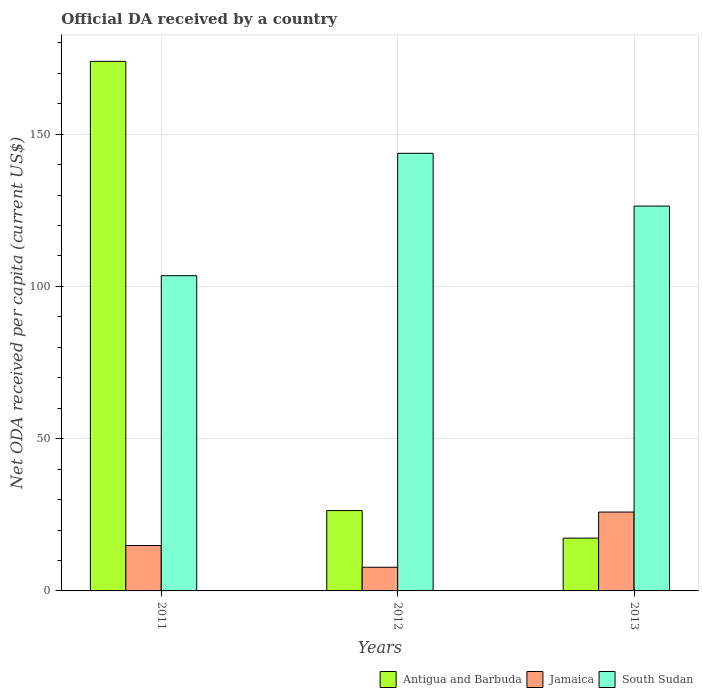How many groups of bars are there?
Make the answer very short. 3. Are the number of bars on each tick of the X-axis equal?
Your answer should be very brief. Yes. In how many cases, is the number of bars for a given year not equal to the number of legend labels?
Your answer should be compact. 0. What is the ODA received in in Jamaica in 2013?
Keep it short and to the point. 25.9. Across all years, what is the maximum ODA received in in Jamaica?
Your answer should be very brief. 25.9. Across all years, what is the minimum ODA received in in South Sudan?
Your answer should be very brief. 103.52. In which year was the ODA received in in Antigua and Barbuda maximum?
Offer a terse response. 2011. In which year was the ODA received in in Jamaica minimum?
Offer a very short reply. 2012. What is the total ODA received in in Antigua and Barbuda in the graph?
Provide a succinct answer. 217.62. What is the difference between the ODA received in in South Sudan in 2012 and that in 2013?
Offer a very short reply. 17.33. What is the difference between the ODA received in in Antigua and Barbuda in 2011 and the ODA received in in Jamaica in 2013?
Provide a succinct answer. 148. What is the average ODA received in in Antigua and Barbuda per year?
Ensure brevity in your answer.  72.54. In the year 2011, what is the difference between the ODA received in in Antigua and Barbuda and ODA received in in Jamaica?
Keep it short and to the point. 159. What is the ratio of the ODA received in in Antigua and Barbuda in 2011 to that in 2013?
Ensure brevity in your answer.  10.03. What is the difference between the highest and the second highest ODA received in in Antigua and Barbuda?
Provide a short and direct response. 147.52. What is the difference between the highest and the lowest ODA received in in Antigua and Barbuda?
Your answer should be compact. 156.57. Is the sum of the ODA received in in Jamaica in 2012 and 2013 greater than the maximum ODA received in in Antigua and Barbuda across all years?
Keep it short and to the point. No. What does the 1st bar from the left in 2012 represents?
Give a very brief answer. Antigua and Barbuda. What does the 2nd bar from the right in 2012 represents?
Your response must be concise. Jamaica. How many bars are there?
Offer a very short reply. 9. Are all the bars in the graph horizontal?
Give a very brief answer. No. Are the values on the major ticks of Y-axis written in scientific E-notation?
Give a very brief answer. No. Where does the legend appear in the graph?
Offer a very short reply. Bottom right. How are the legend labels stacked?
Ensure brevity in your answer.  Horizontal. What is the title of the graph?
Make the answer very short. Official DA received by a country. What is the label or title of the Y-axis?
Your answer should be very brief. Net ODA received per capita (current US$). What is the Net ODA received per capita (current US$) in Antigua and Barbuda in 2011?
Ensure brevity in your answer.  173.9. What is the Net ODA received per capita (current US$) in Jamaica in 2011?
Your answer should be compact. 14.91. What is the Net ODA received per capita (current US$) in South Sudan in 2011?
Give a very brief answer. 103.52. What is the Net ODA received per capita (current US$) of Antigua and Barbuda in 2012?
Give a very brief answer. 26.38. What is the Net ODA received per capita (current US$) in Jamaica in 2012?
Your answer should be very brief. 7.77. What is the Net ODA received per capita (current US$) of South Sudan in 2012?
Make the answer very short. 143.71. What is the Net ODA received per capita (current US$) in Antigua and Barbuda in 2013?
Provide a succinct answer. 17.34. What is the Net ODA received per capita (current US$) in Jamaica in 2013?
Your answer should be compact. 25.9. What is the Net ODA received per capita (current US$) in South Sudan in 2013?
Give a very brief answer. 126.37. Across all years, what is the maximum Net ODA received per capita (current US$) of Antigua and Barbuda?
Offer a terse response. 173.9. Across all years, what is the maximum Net ODA received per capita (current US$) in Jamaica?
Make the answer very short. 25.9. Across all years, what is the maximum Net ODA received per capita (current US$) of South Sudan?
Offer a terse response. 143.71. Across all years, what is the minimum Net ODA received per capita (current US$) of Antigua and Barbuda?
Offer a terse response. 17.34. Across all years, what is the minimum Net ODA received per capita (current US$) in Jamaica?
Make the answer very short. 7.77. Across all years, what is the minimum Net ODA received per capita (current US$) of South Sudan?
Ensure brevity in your answer.  103.52. What is the total Net ODA received per capita (current US$) of Antigua and Barbuda in the graph?
Your response must be concise. 217.62. What is the total Net ODA received per capita (current US$) in Jamaica in the graph?
Your response must be concise. 48.58. What is the total Net ODA received per capita (current US$) of South Sudan in the graph?
Your response must be concise. 373.6. What is the difference between the Net ODA received per capita (current US$) of Antigua and Barbuda in 2011 and that in 2012?
Make the answer very short. 147.52. What is the difference between the Net ODA received per capita (current US$) of Jamaica in 2011 and that in 2012?
Your answer should be compact. 7.13. What is the difference between the Net ODA received per capita (current US$) of South Sudan in 2011 and that in 2012?
Your response must be concise. -40.19. What is the difference between the Net ODA received per capita (current US$) of Antigua and Barbuda in 2011 and that in 2013?
Provide a short and direct response. 156.57. What is the difference between the Net ODA received per capita (current US$) of Jamaica in 2011 and that in 2013?
Provide a short and direct response. -10.99. What is the difference between the Net ODA received per capita (current US$) of South Sudan in 2011 and that in 2013?
Give a very brief answer. -22.85. What is the difference between the Net ODA received per capita (current US$) of Antigua and Barbuda in 2012 and that in 2013?
Ensure brevity in your answer.  9.05. What is the difference between the Net ODA received per capita (current US$) in Jamaica in 2012 and that in 2013?
Make the answer very short. -18.13. What is the difference between the Net ODA received per capita (current US$) in South Sudan in 2012 and that in 2013?
Your response must be concise. 17.33. What is the difference between the Net ODA received per capita (current US$) of Antigua and Barbuda in 2011 and the Net ODA received per capita (current US$) of Jamaica in 2012?
Make the answer very short. 166.13. What is the difference between the Net ODA received per capita (current US$) of Antigua and Barbuda in 2011 and the Net ODA received per capita (current US$) of South Sudan in 2012?
Keep it short and to the point. 30.2. What is the difference between the Net ODA received per capita (current US$) in Jamaica in 2011 and the Net ODA received per capita (current US$) in South Sudan in 2012?
Provide a short and direct response. -128.8. What is the difference between the Net ODA received per capita (current US$) of Antigua and Barbuda in 2011 and the Net ODA received per capita (current US$) of Jamaica in 2013?
Make the answer very short. 148. What is the difference between the Net ODA received per capita (current US$) of Antigua and Barbuda in 2011 and the Net ODA received per capita (current US$) of South Sudan in 2013?
Your answer should be compact. 47.53. What is the difference between the Net ODA received per capita (current US$) in Jamaica in 2011 and the Net ODA received per capita (current US$) in South Sudan in 2013?
Your response must be concise. -111.47. What is the difference between the Net ODA received per capita (current US$) in Antigua and Barbuda in 2012 and the Net ODA received per capita (current US$) in Jamaica in 2013?
Provide a succinct answer. 0.48. What is the difference between the Net ODA received per capita (current US$) in Antigua and Barbuda in 2012 and the Net ODA received per capita (current US$) in South Sudan in 2013?
Your answer should be very brief. -99.99. What is the difference between the Net ODA received per capita (current US$) of Jamaica in 2012 and the Net ODA received per capita (current US$) of South Sudan in 2013?
Offer a terse response. -118.6. What is the average Net ODA received per capita (current US$) of Antigua and Barbuda per year?
Provide a succinct answer. 72.54. What is the average Net ODA received per capita (current US$) in Jamaica per year?
Offer a terse response. 16.19. What is the average Net ODA received per capita (current US$) in South Sudan per year?
Your answer should be compact. 124.53. In the year 2011, what is the difference between the Net ODA received per capita (current US$) of Antigua and Barbuda and Net ODA received per capita (current US$) of Jamaica?
Keep it short and to the point. 159. In the year 2011, what is the difference between the Net ODA received per capita (current US$) of Antigua and Barbuda and Net ODA received per capita (current US$) of South Sudan?
Offer a terse response. 70.38. In the year 2011, what is the difference between the Net ODA received per capita (current US$) of Jamaica and Net ODA received per capita (current US$) of South Sudan?
Provide a succinct answer. -88.61. In the year 2012, what is the difference between the Net ODA received per capita (current US$) in Antigua and Barbuda and Net ODA received per capita (current US$) in Jamaica?
Provide a succinct answer. 18.61. In the year 2012, what is the difference between the Net ODA received per capita (current US$) in Antigua and Barbuda and Net ODA received per capita (current US$) in South Sudan?
Your answer should be very brief. -117.32. In the year 2012, what is the difference between the Net ODA received per capita (current US$) in Jamaica and Net ODA received per capita (current US$) in South Sudan?
Ensure brevity in your answer.  -135.93. In the year 2013, what is the difference between the Net ODA received per capita (current US$) in Antigua and Barbuda and Net ODA received per capita (current US$) in Jamaica?
Offer a terse response. -8.56. In the year 2013, what is the difference between the Net ODA received per capita (current US$) in Antigua and Barbuda and Net ODA received per capita (current US$) in South Sudan?
Keep it short and to the point. -109.04. In the year 2013, what is the difference between the Net ODA received per capita (current US$) of Jamaica and Net ODA received per capita (current US$) of South Sudan?
Your answer should be very brief. -100.47. What is the ratio of the Net ODA received per capita (current US$) of Antigua and Barbuda in 2011 to that in 2012?
Your answer should be compact. 6.59. What is the ratio of the Net ODA received per capita (current US$) in Jamaica in 2011 to that in 2012?
Your response must be concise. 1.92. What is the ratio of the Net ODA received per capita (current US$) of South Sudan in 2011 to that in 2012?
Make the answer very short. 0.72. What is the ratio of the Net ODA received per capita (current US$) of Antigua and Barbuda in 2011 to that in 2013?
Make the answer very short. 10.03. What is the ratio of the Net ODA received per capita (current US$) in Jamaica in 2011 to that in 2013?
Your answer should be compact. 0.58. What is the ratio of the Net ODA received per capita (current US$) of South Sudan in 2011 to that in 2013?
Give a very brief answer. 0.82. What is the ratio of the Net ODA received per capita (current US$) of Antigua and Barbuda in 2012 to that in 2013?
Ensure brevity in your answer.  1.52. What is the ratio of the Net ODA received per capita (current US$) of Jamaica in 2012 to that in 2013?
Offer a terse response. 0.3. What is the ratio of the Net ODA received per capita (current US$) of South Sudan in 2012 to that in 2013?
Make the answer very short. 1.14. What is the difference between the highest and the second highest Net ODA received per capita (current US$) in Antigua and Barbuda?
Keep it short and to the point. 147.52. What is the difference between the highest and the second highest Net ODA received per capita (current US$) in Jamaica?
Offer a very short reply. 10.99. What is the difference between the highest and the second highest Net ODA received per capita (current US$) of South Sudan?
Ensure brevity in your answer.  17.33. What is the difference between the highest and the lowest Net ODA received per capita (current US$) of Antigua and Barbuda?
Your answer should be very brief. 156.57. What is the difference between the highest and the lowest Net ODA received per capita (current US$) of Jamaica?
Provide a succinct answer. 18.13. What is the difference between the highest and the lowest Net ODA received per capita (current US$) of South Sudan?
Provide a succinct answer. 40.19. 